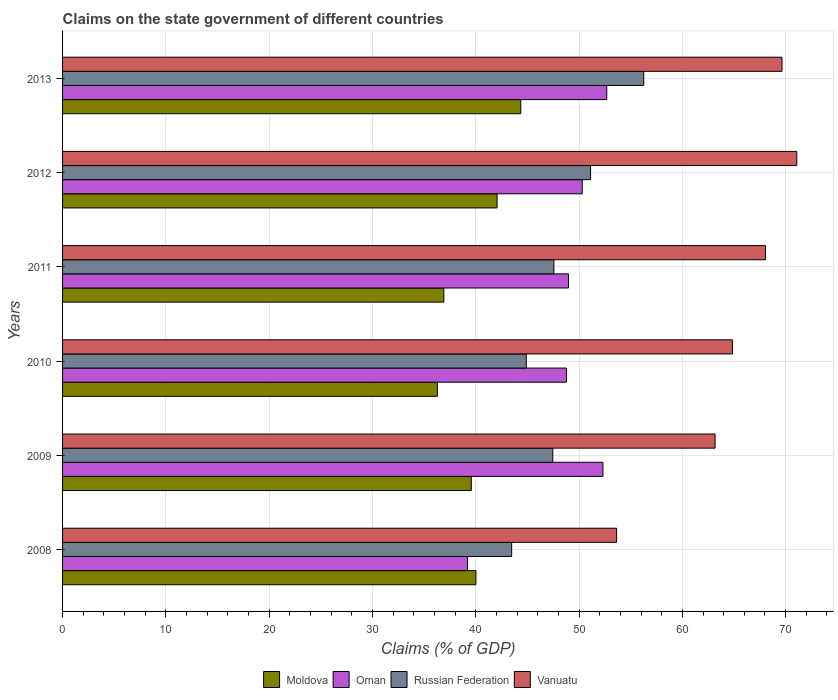How many groups of bars are there?
Ensure brevity in your answer.  6. What is the label of the 1st group of bars from the top?
Keep it short and to the point. 2013. What is the percentage of GDP claimed on the state government in Vanuatu in 2012?
Your answer should be very brief. 71.08. Across all years, what is the maximum percentage of GDP claimed on the state government in Moldova?
Provide a succinct answer. 44.36. Across all years, what is the minimum percentage of GDP claimed on the state government in Russian Federation?
Your answer should be very brief. 43.48. In which year was the percentage of GDP claimed on the state government in Oman maximum?
Keep it short and to the point. 2013. In which year was the percentage of GDP claimed on the state government in Russian Federation minimum?
Make the answer very short. 2008. What is the total percentage of GDP claimed on the state government in Vanuatu in the graph?
Keep it short and to the point. 390.43. What is the difference between the percentage of GDP claimed on the state government in Oman in 2009 and that in 2010?
Offer a very short reply. 3.53. What is the difference between the percentage of GDP claimed on the state government in Moldova in 2009 and the percentage of GDP claimed on the state government in Russian Federation in 2011?
Your answer should be very brief. -8. What is the average percentage of GDP claimed on the state government in Vanuatu per year?
Your response must be concise. 65.07. In the year 2009, what is the difference between the percentage of GDP claimed on the state government in Vanuatu and percentage of GDP claimed on the state government in Russian Federation?
Give a very brief answer. 15.71. What is the ratio of the percentage of GDP claimed on the state government in Vanuatu in 2008 to that in 2010?
Your answer should be very brief. 0.83. Is the percentage of GDP claimed on the state government in Oman in 2008 less than that in 2011?
Keep it short and to the point. Yes. What is the difference between the highest and the second highest percentage of GDP claimed on the state government in Oman?
Make the answer very short. 0.37. What is the difference between the highest and the lowest percentage of GDP claimed on the state government in Vanuatu?
Your response must be concise. 17.44. Is the sum of the percentage of GDP claimed on the state government in Oman in 2010 and 2011 greater than the maximum percentage of GDP claimed on the state government in Vanuatu across all years?
Make the answer very short. Yes. Is it the case that in every year, the sum of the percentage of GDP claimed on the state government in Russian Federation and percentage of GDP claimed on the state government in Oman is greater than the sum of percentage of GDP claimed on the state government in Vanuatu and percentage of GDP claimed on the state government in Moldova?
Your answer should be compact. No. What does the 4th bar from the top in 2010 represents?
Offer a terse response. Moldova. What does the 1st bar from the bottom in 2009 represents?
Your answer should be very brief. Moldova. How many bars are there?
Provide a short and direct response. 24. How many years are there in the graph?
Your answer should be compact. 6. What is the difference between two consecutive major ticks on the X-axis?
Offer a terse response. 10. Does the graph contain any zero values?
Provide a short and direct response. No. How are the legend labels stacked?
Provide a succinct answer. Horizontal. What is the title of the graph?
Make the answer very short. Claims on the state government of different countries. What is the label or title of the X-axis?
Make the answer very short. Claims (% of GDP). What is the Claims (% of GDP) in Moldova in 2008?
Offer a terse response. 40.02. What is the Claims (% of GDP) of Oman in 2008?
Make the answer very short. 39.2. What is the Claims (% of GDP) of Russian Federation in 2008?
Your response must be concise. 43.48. What is the Claims (% of GDP) of Vanuatu in 2008?
Provide a short and direct response. 53.63. What is the Claims (% of GDP) in Moldova in 2009?
Offer a very short reply. 39.57. What is the Claims (% of GDP) of Oman in 2009?
Your response must be concise. 52.31. What is the Claims (% of GDP) of Russian Federation in 2009?
Offer a very short reply. 47.45. What is the Claims (% of GDP) in Vanuatu in 2009?
Provide a short and direct response. 63.17. What is the Claims (% of GDP) of Moldova in 2010?
Provide a short and direct response. 36.29. What is the Claims (% of GDP) of Oman in 2010?
Ensure brevity in your answer.  48.78. What is the Claims (% of GDP) of Russian Federation in 2010?
Keep it short and to the point. 44.89. What is the Claims (% of GDP) of Vanuatu in 2010?
Make the answer very short. 64.85. What is the Claims (% of GDP) of Moldova in 2011?
Make the answer very short. 36.91. What is the Claims (% of GDP) in Oman in 2011?
Give a very brief answer. 48.98. What is the Claims (% of GDP) of Russian Federation in 2011?
Make the answer very short. 47.56. What is the Claims (% of GDP) in Vanuatu in 2011?
Offer a terse response. 68.05. What is the Claims (% of GDP) in Moldova in 2012?
Make the answer very short. 42.06. What is the Claims (% of GDP) of Oman in 2012?
Offer a terse response. 50.31. What is the Claims (% of GDP) of Russian Federation in 2012?
Provide a short and direct response. 51.11. What is the Claims (% of GDP) in Vanuatu in 2012?
Provide a succinct answer. 71.08. What is the Claims (% of GDP) in Moldova in 2013?
Offer a terse response. 44.36. What is the Claims (% of GDP) of Oman in 2013?
Your response must be concise. 52.68. What is the Claims (% of GDP) of Russian Federation in 2013?
Give a very brief answer. 56.26. What is the Claims (% of GDP) in Vanuatu in 2013?
Offer a terse response. 69.65. Across all years, what is the maximum Claims (% of GDP) in Moldova?
Your answer should be very brief. 44.36. Across all years, what is the maximum Claims (% of GDP) in Oman?
Provide a succinct answer. 52.68. Across all years, what is the maximum Claims (% of GDP) of Russian Federation?
Your answer should be compact. 56.26. Across all years, what is the maximum Claims (% of GDP) in Vanuatu?
Your response must be concise. 71.08. Across all years, what is the minimum Claims (% of GDP) in Moldova?
Ensure brevity in your answer.  36.29. Across all years, what is the minimum Claims (% of GDP) of Oman?
Give a very brief answer. 39.2. Across all years, what is the minimum Claims (% of GDP) in Russian Federation?
Provide a succinct answer. 43.48. Across all years, what is the minimum Claims (% of GDP) in Vanuatu?
Make the answer very short. 53.63. What is the total Claims (% of GDP) in Moldova in the graph?
Provide a short and direct response. 239.2. What is the total Claims (% of GDP) in Oman in the graph?
Provide a succinct answer. 292.27. What is the total Claims (% of GDP) in Russian Federation in the graph?
Keep it short and to the point. 290.76. What is the total Claims (% of GDP) of Vanuatu in the graph?
Provide a short and direct response. 390.43. What is the difference between the Claims (% of GDP) in Moldova in 2008 and that in 2009?
Give a very brief answer. 0.45. What is the difference between the Claims (% of GDP) of Oman in 2008 and that in 2009?
Keep it short and to the point. -13.11. What is the difference between the Claims (% of GDP) of Russian Federation in 2008 and that in 2009?
Your response must be concise. -3.98. What is the difference between the Claims (% of GDP) of Vanuatu in 2008 and that in 2009?
Your answer should be compact. -9.53. What is the difference between the Claims (% of GDP) in Moldova in 2008 and that in 2010?
Provide a short and direct response. 3.73. What is the difference between the Claims (% of GDP) in Oman in 2008 and that in 2010?
Provide a succinct answer. -9.58. What is the difference between the Claims (% of GDP) of Russian Federation in 2008 and that in 2010?
Offer a terse response. -1.41. What is the difference between the Claims (% of GDP) of Vanuatu in 2008 and that in 2010?
Offer a terse response. -11.21. What is the difference between the Claims (% of GDP) in Moldova in 2008 and that in 2011?
Provide a succinct answer. 3.11. What is the difference between the Claims (% of GDP) of Oman in 2008 and that in 2011?
Provide a succinct answer. -9.77. What is the difference between the Claims (% of GDP) of Russian Federation in 2008 and that in 2011?
Ensure brevity in your answer.  -4.09. What is the difference between the Claims (% of GDP) in Vanuatu in 2008 and that in 2011?
Give a very brief answer. -14.42. What is the difference between the Claims (% of GDP) in Moldova in 2008 and that in 2012?
Your answer should be very brief. -2.05. What is the difference between the Claims (% of GDP) of Oman in 2008 and that in 2012?
Your response must be concise. -11.1. What is the difference between the Claims (% of GDP) of Russian Federation in 2008 and that in 2012?
Offer a very short reply. -7.64. What is the difference between the Claims (% of GDP) of Vanuatu in 2008 and that in 2012?
Offer a terse response. -17.44. What is the difference between the Claims (% of GDP) of Moldova in 2008 and that in 2013?
Ensure brevity in your answer.  -4.34. What is the difference between the Claims (% of GDP) of Oman in 2008 and that in 2013?
Your answer should be very brief. -13.48. What is the difference between the Claims (% of GDP) of Russian Federation in 2008 and that in 2013?
Give a very brief answer. -12.79. What is the difference between the Claims (% of GDP) of Vanuatu in 2008 and that in 2013?
Provide a succinct answer. -16.01. What is the difference between the Claims (% of GDP) of Moldova in 2009 and that in 2010?
Provide a short and direct response. 3.28. What is the difference between the Claims (% of GDP) of Oman in 2009 and that in 2010?
Ensure brevity in your answer.  3.53. What is the difference between the Claims (% of GDP) of Russian Federation in 2009 and that in 2010?
Give a very brief answer. 2.57. What is the difference between the Claims (% of GDP) of Vanuatu in 2009 and that in 2010?
Your answer should be compact. -1.68. What is the difference between the Claims (% of GDP) of Moldova in 2009 and that in 2011?
Offer a terse response. 2.66. What is the difference between the Claims (% of GDP) in Oman in 2009 and that in 2011?
Your response must be concise. 3.34. What is the difference between the Claims (% of GDP) in Russian Federation in 2009 and that in 2011?
Provide a short and direct response. -0.11. What is the difference between the Claims (% of GDP) of Vanuatu in 2009 and that in 2011?
Provide a short and direct response. -4.89. What is the difference between the Claims (% of GDP) of Moldova in 2009 and that in 2012?
Offer a terse response. -2.5. What is the difference between the Claims (% of GDP) of Oman in 2009 and that in 2012?
Your answer should be very brief. 2.01. What is the difference between the Claims (% of GDP) of Russian Federation in 2009 and that in 2012?
Make the answer very short. -3.66. What is the difference between the Claims (% of GDP) of Vanuatu in 2009 and that in 2012?
Offer a very short reply. -7.91. What is the difference between the Claims (% of GDP) in Moldova in 2009 and that in 2013?
Make the answer very short. -4.79. What is the difference between the Claims (% of GDP) in Oman in 2009 and that in 2013?
Provide a succinct answer. -0.37. What is the difference between the Claims (% of GDP) of Russian Federation in 2009 and that in 2013?
Keep it short and to the point. -8.81. What is the difference between the Claims (% of GDP) in Vanuatu in 2009 and that in 2013?
Provide a succinct answer. -6.48. What is the difference between the Claims (% of GDP) of Moldova in 2010 and that in 2011?
Your answer should be compact. -0.62. What is the difference between the Claims (% of GDP) of Oman in 2010 and that in 2011?
Provide a short and direct response. -0.19. What is the difference between the Claims (% of GDP) in Russian Federation in 2010 and that in 2011?
Your answer should be very brief. -2.68. What is the difference between the Claims (% of GDP) in Vanuatu in 2010 and that in 2011?
Keep it short and to the point. -3.21. What is the difference between the Claims (% of GDP) in Moldova in 2010 and that in 2012?
Keep it short and to the point. -5.78. What is the difference between the Claims (% of GDP) in Oman in 2010 and that in 2012?
Offer a terse response. -1.52. What is the difference between the Claims (% of GDP) in Russian Federation in 2010 and that in 2012?
Your answer should be compact. -6.23. What is the difference between the Claims (% of GDP) in Vanuatu in 2010 and that in 2012?
Provide a succinct answer. -6.23. What is the difference between the Claims (% of GDP) of Moldova in 2010 and that in 2013?
Give a very brief answer. -8.07. What is the difference between the Claims (% of GDP) of Oman in 2010 and that in 2013?
Ensure brevity in your answer.  -3.9. What is the difference between the Claims (% of GDP) in Russian Federation in 2010 and that in 2013?
Your answer should be very brief. -11.38. What is the difference between the Claims (% of GDP) of Vanuatu in 2010 and that in 2013?
Provide a succinct answer. -4.8. What is the difference between the Claims (% of GDP) in Moldova in 2011 and that in 2012?
Ensure brevity in your answer.  -5.15. What is the difference between the Claims (% of GDP) of Oman in 2011 and that in 2012?
Your answer should be compact. -1.33. What is the difference between the Claims (% of GDP) of Russian Federation in 2011 and that in 2012?
Your answer should be very brief. -3.55. What is the difference between the Claims (% of GDP) in Vanuatu in 2011 and that in 2012?
Keep it short and to the point. -3.02. What is the difference between the Claims (% of GDP) in Moldova in 2011 and that in 2013?
Offer a very short reply. -7.45. What is the difference between the Claims (% of GDP) of Oman in 2011 and that in 2013?
Ensure brevity in your answer.  -3.71. What is the difference between the Claims (% of GDP) in Russian Federation in 2011 and that in 2013?
Provide a succinct answer. -8.7. What is the difference between the Claims (% of GDP) of Vanuatu in 2011 and that in 2013?
Your answer should be very brief. -1.59. What is the difference between the Claims (% of GDP) in Moldova in 2012 and that in 2013?
Your response must be concise. -2.29. What is the difference between the Claims (% of GDP) of Oman in 2012 and that in 2013?
Offer a terse response. -2.38. What is the difference between the Claims (% of GDP) of Russian Federation in 2012 and that in 2013?
Your answer should be compact. -5.15. What is the difference between the Claims (% of GDP) in Vanuatu in 2012 and that in 2013?
Make the answer very short. 1.43. What is the difference between the Claims (% of GDP) of Moldova in 2008 and the Claims (% of GDP) of Oman in 2009?
Your answer should be very brief. -12.3. What is the difference between the Claims (% of GDP) of Moldova in 2008 and the Claims (% of GDP) of Russian Federation in 2009?
Ensure brevity in your answer.  -7.44. What is the difference between the Claims (% of GDP) in Moldova in 2008 and the Claims (% of GDP) in Vanuatu in 2009?
Give a very brief answer. -23.15. What is the difference between the Claims (% of GDP) in Oman in 2008 and the Claims (% of GDP) in Russian Federation in 2009?
Your response must be concise. -8.25. What is the difference between the Claims (% of GDP) of Oman in 2008 and the Claims (% of GDP) of Vanuatu in 2009?
Provide a succinct answer. -23.96. What is the difference between the Claims (% of GDP) in Russian Federation in 2008 and the Claims (% of GDP) in Vanuatu in 2009?
Your response must be concise. -19.69. What is the difference between the Claims (% of GDP) in Moldova in 2008 and the Claims (% of GDP) in Oman in 2010?
Your response must be concise. -8.77. What is the difference between the Claims (% of GDP) in Moldova in 2008 and the Claims (% of GDP) in Russian Federation in 2010?
Your answer should be compact. -4.87. What is the difference between the Claims (% of GDP) of Moldova in 2008 and the Claims (% of GDP) of Vanuatu in 2010?
Your answer should be compact. -24.83. What is the difference between the Claims (% of GDP) in Oman in 2008 and the Claims (% of GDP) in Russian Federation in 2010?
Give a very brief answer. -5.68. What is the difference between the Claims (% of GDP) of Oman in 2008 and the Claims (% of GDP) of Vanuatu in 2010?
Provide a short and direct response. -25.64. What is the difference between the Claims (% of GDP) in Russian Federation in 2008 and the Claims (% of GDP) in Vanuatu in 2010?
Your answer should be very brief. -21.37. What is the difference between the Claims (% of GDP) of Moldova in 2008 and the Claims (% of GDP) of Oman in 2011?
Provide a succinct answer. -8.96. What is the difference between the Claims (% of GDP) of Moldova in 2008 and the Claims (% of GDP) of Russian Federation in 2011?
Ensure brevity in your answer.  -7.55. What is the difference between the Claims (% of GDP) in Moldova in 2008 and the Claims (% of GDP) in Vanuatu in 2011?
Your response must be concise. -28.04. What is the difference between the Claims (% of GDP) in Oman in 2008 and the Claims (% of GDP) in Russian Federation in 2011?
Keep it short and to the point. -8.36. What is the difference between the Claims (% of GDP) in Oman in 2008 and the Claims (% of GDP) in Vanuatu in 2011?
Keep it short and to the point. -28.85. What is the difference between the Claims (% of GDP) of Russian Federation in 2008 and the Claims (% of GDP) of Vanuatu in 2011?
Your answer should be very brief. -24.58. What is the difference between the Claims (% of GDP) in Moldova in 2008 and the Claims (% of GDP) in Oman in 2012?
Offer a terse response. -10.29. What is the difference between the Claims (% of GDP) in Moldova in 2008 and the Claims (% of GDP) in Russian Federation in 2012?
Provide a short and direct response. -11.1. What is the difference between the Claims (% of GDP) of Moldova in 2008 and the Claims (% of GDP) of Vanuatu in 2012?
Your answer should be very brief. -31.06. What is the difference between the Claims (% of GDP) in Oman in 2008 and the Claims (% of GDP) in Russian Federation in 2012?
Make the answer very short. -11.91. What is the difference between the Claims (% of GDP) of Oman in 2008 and the Claims (% of GDP) of Vanuatu in 2012?
Make the answer very short. -31.87. What is the difference between the Claims (% of GDP) of Russian Federation in 2008 and the Claims (% of GDP) of Vanuatu in 2012?
Offer a very short reply. -27.6. What is the difference between the Claims (% of GDP) of Moldova in 2008 and the Claims (% of GDP) of Oman in 2013?
Your answer should be very brief. -12.67. What is the difference between the Claims (% of GDP) in Moldova in 2008 and the Claims (% of GDP) in Russian Federation in 2013?
Ensure brevity in your answer.  -16.25. What is the difference between the Claims (% of GDP) in Moldova in 2008 and the Claims (% of GDP) in Vanuatu in 2013?
Offer a very short reply. -29.63. What is the difference between the Claims (% of GDP) of Oman in 2008 and the Claims (% of GDP) of Russian Federation in 2013?
Ensure brevity in your answer.  -17.06. What is the difference between the Claims (% of GDP) in Oman in 2008 and the Claims (% of GDP) in Vanuatu in 2013?
Provide a succinct answer. -30.44. What is the difference between the Claims (% of GDP) in Russian Federation in 2008 and the Claims (% of GDP) in Vanuatu in 2013?
Offer a terse response. -26.17. What is the difference between the Claims (% of GDP) in Moldova in 2009 and the Claims (% of GDP) in Oman in 2010?
Make the answer very short. -9.21. What is the difference between the Claims (% of GDP) of Moldova in 2009 and the Claims (% of GDP) of Russian Federation in 2010?
Provide a succinct answer. -5.32. What is the difference between the Claims (% of GDP) in Moldova in 2009 and the Claims (% of GDP) in Vanuatu in 2010?
Make the answer very short. -25.28. What is the difference between the Claims (% of GDP) of Oman in 2009 and the Claims (% of GDP) of Russian Federation in 2010?
Ensure brevity in your answer.  7.42. What is the difference between the Claims (% of GDP) of Oman in 2009 and the Claims (% of GDP) of Vanuatu in 2010?
Your answer should be compact. -12.54. What is the difference between the Claims (% of GDP) in Russian Federation in 2009 and the Claims (% of GDP) in Vanuatu in 2010?
Keep it short and to the point. -17.39. What is the difference between the Claims (% of GDP) in Moldova in 2009 and the Claims (% of GDP) in Oman in 2011?
Your answer should be very brief. -9.41. What is the difference between the Claims (% of GDP) in Moldova in 2009 and the Claims (% of GDP) in Russian Federation in 2011?
Provide a short and direct response. -8. What is the difference between the Claims (% of GDP) of Moldova in 2009 and the Claims (% of GDP) of Vanuatu in 2011?
Your answer should be very brief. -28.49. What is the difference between the Claims (% of GDP) of Oman in 2009 and the Claims (% of GDP) of Russian Federation in 2011?
Your answer should be compact. 4.75. What is the difference between the Claims (% of GDP) of Oman in 2009 and the Claims (% of GDP) of Vanuatu in 2011?
Ensure brevity in your answer.  -15.74. What is the difference between the Claims (% of GDP) of Russian Federation in 2009 and the Claims (% of GDP) of Vanuatu in 2011?
Provide a succinct answer. -20.6. What is the difference between the Claims (% of GDP) of Moldova in 2009 and the Claims (% of GDP) of Oman in 2012?
Ensure brevity in your answer.  -10.74. What is the difference between the Claims (% of GDP) in Moldova in 2009 and the Claims (% of GDP) in Russian Federation in 2012?
Keep it short and to the point. -11.55. What is the difference between the Claims (% of GDP) of Moldova in 2009 and the Claims (% of GDP) of Vanuatu in 2012?
Offer a very short reply. -31.51. What is the difference between the Claims (% of GDP) in Oman in 2009 and the Claims (% of GDP) in Russian Federation in 2012?
Offer a very short reply. 1.2. What is the difference between the Claims (% of GDP) of Oman in 2009 and the Claims (% of GDP) of Vanuatu in 2012?
Your answer should be compact. -18.77. What is the difference between the Claims (% of GDP) of Russian Federation in 2009 and the Claims (% of GDP) of Vanuatu in 2012?
Keep it short and to the point. -23.62. What is the difference between the Claims (% of GDP) in Moldova in 2009 and the Claims (% of GDP) in Oman in 2013?
Provide a short and direct response. -13.11. What is the difference between the Claims (% of GDP) in Moldova in 2009 and the Claims (% of GDP) in Russian Federation in 2013?
Your answer should be compact. -16.7. What is the difference between the Claims (% of GDP) of Moldova in 2009 and the Claims (% of GDP) of Vanuatu in 2013?
Provide a succinct answer. -30.08. What is the difference between the Claims (% of GDP) in Oman in 2009 and the Claims (% of GDP) in Russian Federation in 2013?
Make the answer very short. -3.95. What is the difference between the Claims (% of GDP) in Oman in 2009 and the Claims (% of GDP) in Vanuatu in 2013?
Make the answer very short. -17.34. What is the difference between the Claims (% of GDP) in Russian Federation in 2009 and the Claims (% of GDP) in Vanuatu in 2013?
Provide a succinct answer. -22.19. What is the difference between the Claims (% of GDP) in Moldova in 2010 and the Claims (% of GDP) in Oman in 2011?
Offer a terse response. -12.69. What is the difference between the Claims (% of GDP) of Moldova in 2010 and the Claims (% of GDP) of Russian Federation in 2011?
Ensure brevity in your answer.  -11.28. What is the difference between the Claims (% of GDP) of Moldova in 2010 and the Claims (% of GDP) of Vanuatu in 2011?
Ensure brevity in your answer.  -31.77. What is the difference between the Claims (% of GDP) of Oman in 2010 and the Claims (% of GDP) of Russian Federation in 2011?
Ensure brevity in your answer.  1.22. What is the difference between the Claims (% of GDP) in Oman in 2010 and the Claims (% of GDP) in Vanuatu in 2011?
Provide a short and direct response. -19.27. What is the difference between the Claims (% of GDP) of Russian Federation in 2010 and the Claims (% of GDP) of Vanuatu in 2011?
Provide a succinct answer. -23.17. What is the difference between the Claims (% of GDP) in Moldova in 2010 and the Claims (% of GDP) in Oman in 2012?
Provide a short and direct response. -14.02. What is the difference between the Claims (% of GDP) of Moldova in 2010 and the Claims (% of GDP) of Russian Federation in 2012?
Ensure brevity in your answer.  -14.83. What is the difference between the Claims (% of GDP) of Moldova in 2010 and the Claims (% of GDP) of Vanuatu in 2012?
Offer a very short reply. -34.79. What is the difference between the Claims (% of GDP) of Oman in 2010 and the Claims (% of GDP) of Russian Federation in 2012?
Your answer should be compact. -2.33. What is the difference between the Claims (% of GDP) of Oman in 2010 and the Claims (% of GDP) of Vanuatu in 2012?
Make the answer very short. -22.3. What is the difference between the Claims (% of GDP) in Russian Federation in 2010 and the Claims (% of GDP) in Vanuatu in 2012?
Your answer should be compact. -26.19. What is the difference between the Claims (% of GDP) of Moldova in 2010 and the Claims (% of GDP) of Oman in 2013?
Keep it short and to the point. -16.4. What is the difference between the Claims (% of GDP) in Moldova in 2010 and the Claims (% of GDP) in Russian Federation in 2013?
Ensure brevity in your answer.  -19.98. What is the difference between the Claims (% of GDP) in Moldova in 2010 and the Claims (% of GDP) in Vanuatu in 2013?
Offer a very short reply. -33.36. What is the difference between the Claims (% of GDP) of Oman in 2010 and the Claims (% of GDP) of Russian Federation in 2013?
Offer a very short reply. -7.48. What is the difference between the Claims (% of GDP) of Oman in 2010 and the Claims (% of GDP) of Vanuatu in 2013?
Offer a very short reply. -20.87. What is the difference between the Claims (% of GDP) in Russian Federation in 2010 and the Claims (% of GDP) in Vanuatu in 2013?
Offer a very short reply. -24.76. What is the difference between the Claims (% of GDP) in Moldova in 2011 and the Claims (% of GDP) in Oman in 2012?
Provide a succinct answer. -13.4. What is the difference between the Claims (% of GDP) in Moldova in 2011 and the Claims (% of GDP) in Russian Federation in 2012?
Your answer should be very brief. -14.2. What is the difference between the Claims (% of GDP) of Moldova in 2011 and the Claims (% of GDP) of Vanuatu in 2012?
Your response must be concise. -34.17. What is the difference between the Claims (% of GDP) in Oman in 2011 and the Claims (% of GDP) in Russian Federation in 2012?
Ensure brevity in your answer.  -2.14. What is the difference between the Claims (% of GDP) in Oman in 2011 and the Claims (% of GDP) in Vanuatu in 2012?
Your response must be concise. -22.1. What is the difference between the Claims (% of GDP) in Russian Federation in 2011 and the Claims (% of GDP) in Vanuatu in 2012?
Offer a terse response. -23.51. What is the difference between the Claims (% of GDP) of Moldova in 2011 and the Claims (% of GDP) of Oman in 2013?
Make the answer very short. -15.77. What is the difference between the Claims (% of GDP) of Moldova in 2011 and the Claims (% of GDP) of Russian Federation in 2013?
Keep it short and to the point. -19.35. What is the difference between the Claims (% of GDP) in Moldova in 2011 and the Claims (% of GDP) in Vanuatu in 2013?
Make the answer very short. -32.74. What is the difference between the Claims (% of GDP) of Oman in 2011 and the Claims (% of GDP) of Russian Federation in 2013?
Give a very brief answer. -7.29. What is the difference between the Claims (% of GDP) of Oman in 2011 and the Claims (% of GDP) of Vanuatu in 2013?
Your answer should be very brief. -20.67. What is the difference between the Claims (% of GDP) in Russian Federation in 2011 and the Claims (% of GDP) in Vanuatu in 2013?
Your answer should be compact. -22.08. What is the difference between the Claims (% of GDP) in Moldova in 2012 and the Claims (% of GDP) in Oman in 2013?
Your response must be concise. -10.62. What is the difference between the Claims (% of GDP) in Moldova in 2012 and the Claims (% of GDP) in Russian Federation in 2013?
Offer a very short reply. -14.2. What is the difference between the Claims (% of GDP) in Moldova in 2012 and the Claims (% of GDP) in Vanuatu in 2013?
Make the answer very short. -27.58. What is the difference between the Claims (% of GDP) of Oman in 2012 and the Claims (% of GDP) of Russian Federation in 2013?
Ensure brevity in your answer.  -5.96. What is the difference between the Claims (% of GDP) of Oman in 2012 and the Claims (% of GDP) of Vanuatu in 2013?
Your response must be concise. -19.34. What is the difference between the Claims (% of GDP) of Russian Federation in 2012 and the Claims (% of GDP) of Vanuatu in 2013?
Give a very brief answer. -18.53. What is the average Claims (% of GDP) of Moldova per year?
Make the answer very short. 39.87. What is the average Claims (% of GDP) in Oman per year?
Offer a very short reply. 48.71. What is the average Claims (% of GDP) of Russian Federation per year?
Your response must be concise. 48.46. What is the average Claims (% of GDP) in Vanuatu per year?
Give a very brief answer. 65.07. In the year 2008, what is the difference between the Claims (% of GDP) in Moldova and Claims (% of GDP) in Oman?
Keep it short and to the point. 0.81. In the year 2008, what is the difference between the Claims (% of GDP) of Moldova and Claims (% of GDP) of Russian Federation?
Offer a terse response. -3.46. In the year 2008, what is the difference between the Claims (% of GDP) in Moldova and Claims (% of GDP) in Vanuatu?
Provide a short and direct response. -13.62. In the year 2008, what is the difference between the Claims (% of GDP) of Oman and Claims (% of GDP) of Russian Federation?
Offer a terse response. -4.27. In the year 2008, what is the difference between the Claims (% of GDP) of Oman and Claims (% of GDP) of Vanuatu?
Offer a terse response. -14.43. In the year 2008, what is the difference between the Claims (% of GDP) in Russian Federation and Claims (% of GDP) in Vanuatu?
Your answer should be compact. -10.16. In the year 2009, what is the difference between the Claims (% of GDP) of Moldova and Claims (% of GDP) of Oman?
Your response must be concise. -12.74. In the year 2009, what is the difference between the Claims (% of GDP) in Moldova and Claims (% of GDP) in Russian Federation?
Offer a very short reply. -7.89. In the year 2009, what is the difference between the Claims (% of GDP) in Moldova and Claims (% of GDP) in Vanuatu?
Keep it short and to the point. -23.6. In the year 2009, what is the difference between the Claims (% of GDP) of Oman and Claims (% of GDP) of Russian Federation?
Your answer should be very brief. 4.86. In the year 2009, what is the difference between the Claims (% of GDP) in Oman and Claims (% of GDP) in Vanuatu?
Offer a very short reply. -10.86. In the year 2009, what is the difference between the Claims (% of GDP) of Russian Federation and Claims (% of GDP) of Vanuatu?
Ensure brevity in your answer.  -15.71. In the year 2010, what is the difference between the Claims (% of GDP) of Moldova and Claims (% of GDP) of Oman?
Provide a succinct answer. -12.5. In the year 2010, what is the difference between the Claims (% of GDP) of Moldova and Claims (% of GDP) of Russian Federation?
Ensure brevity in your answer.  -8.6. In the year 2010, what is the difference between the Claims (% of GDP) of Moldova and Claims (% of GDP) of Vanuatu?
Offer a terse response. -28.56. In the year 2010, what is the difference between the Claims (% of GDP) of Oman and Claims (% of GDP) of Russian Federation?
Offer a very short reply. 3.9. In the year 2010, what is the difference between the Claims (% of GDP) of Oman and Claims (% of GDP) of Vanuatu?
Your answer should be very brief. -16.07. In the year 2010, what is the difference between the Claims (% of GDP) of Russian Federation and Claims (% of GDP) of Vanuatu?
Ensure brevity in your answer.  -19.96. In the year 2011, what is the difference between the Claims (% of GDP) in Moldova and Claims (% of GDP) in Oman?
Your response must be concise. -12.07. In the year 2011, what is the difference between the Claims (% of GDP) of Moldova and Claims (% of GDP) of Russian Federation?
Your answer should be very brief. -10.65. In the year 2011, what is the difference between the Claims (% of GDP) of Moldova and Claims (% of GDP) of Vanuatu?
Your response must be concise. -31.14. In the year 2011, what is the difference between the Claims (% of GDP) in Oman and Claims (% of GDP) in Russian Federation?
Offer a very short reply. 1.41. In the year 2011, what is the difference between the Claims (% of GDP) in Oman and Claims (% of GDP) in Vanuatu?
Give a very brief answer. -19.08. In the year 2011, what is the difference between the Claims (% of GDP) in Russian Federation and Claims (% of GDP) in Vanuatu?
Provide a short and direct response. -20.49. In the year 2012, what is the difference between the Claims (% of GDP) of Moldova and Claims (% of GDP) of Oman?
Offer a terse response. -8.24. In the year 2012, what is the difference between the Claims (% of GDP) of Moldova and Claims (% of GDP) of Russian Federation?
Give a very brief answer. -9.05. In the year 2012, what is the difference between the Claims (% of GDP) in Moldova and Claims (% of GDP) in Vanuatu?
Ensure brevity in your answer.  -29.01. In the year 2012, what is the difference between the Claims (% of GDP) in Oman and Claims (% of GDP) in Russian Federation?
Give a very brief answer. -0.81. In the year 2012, what is the difference between the Claims (% of GDP) in Oman and Claims (% of GDP) in Vanuatu?
Provide a short and direct response. -20.77. In the year 2012, what is the difference between the Claims (% of GDP) of Russian Federation and Claims (% of GDP) of Vanuatu?
Give a very brief answer. -19.96. In the year 2013, what is the difference between the Claims (% of GDP) of Moldova and Claims (% of GDP) of Oman?
Your response must be concise. -8.32. In the year 2013, what is the difference between the Claims (% of GDP) in Moldova and Claims (% of GDP) in Russian Federation?
Offer a terse response. -11.91. In the year 2013, what is the difference between the Claims (% of GDP) in Moldova and Claims (% of GDP) in Vanuatu?
Keep it short and to the point. -25.29. In the year 2013, what is the difference between the Claims (% of GDP) in Oman and Claims (% of GDP) in Russian Federation?
Offer a very short reply. -3.58. In the year 2013, what is the difference between the Claims (% of GDP) in Oman and Claims (% of GDP) in Vanuatu?
Give a very brief answer. -16.97. In the year 2013, what is the difference between the Claims (% of GDP) of Russian Federation and Claims (% of GDP) of Vanuatu?
Your answer should be very brief. -13.39. What is the ratio of the Claims (% of GDP) in Moldova in 2008 to that in 2009?
Give a very brief answer. 1.01. What is the ratio of the Claims (% of GDP) in Oman in 2008 to that in 2009?
Make the answer very short. 0.75. What is the ratio of the Claims (% of GDP) in Russian Federation in 2008 to that in 2009?
Your answer should be very brief. 0.92. What is the ratio of the Claims (% of GDP) in Vanuatu in 2008 to that in 2009?
Make the answer very short. 0.85. What is the ratio of the Claims (% of GDP) of Moldova in 2008 to that in 2010?
Provide a short and direct response. 1.1. What is the ratio of the Claims (% of GDP) in Oman in 2008 to that in 2010?
Your response must be concise. 0.8. What is the ratio of the Claims (% of GDP) of Russian Federation in 2008 to that in 2010?
Your answer should be very brief. 0.97. What is the ratio of the Claims (% of GDP) in Vanuatu in 2008 to that in 2010?
Offer a terse response. 0.83. What is the ratio of the Claims (% of GDP) in Moldova in 2008 to that in 2011?
Provide a short and direct response. 1.08. What is the ratio of the Claims (% of GDP) of Oman in 2008 to that in 2011?
Give a very brief answer. 0.8. What is the ratio of the Claims (% of GDP) of Russian Federation in 2008 to that in 2011?
Provide a succinct answer. 0.91. What is the ratio of the Claims (% of GDP) of Vanuatu in 2008 to that in 2011?
Offer a terse response. 0.79. What is the ratio of the Claims (% of GDP) of Moldova in 2008 to that in 2012?
Give a very brief answer. 0.95. What is the ratio of the Claims (% of GDP) of Oman in 2008 to that in 2012?
Make the answer very short. 0.78. What is the ratio of the Claims (% of GDP) of Russian Federation in 2008 to that in 2012?
Your response must be concise. 0.85. What is the ratio of the Claims (% of GDP) of Vanuatu in 2008 to that in 2012?
Offer a very short reply. 0.75. What is the ratio of the Claims (% of GDP) in Moldova in 2008 to that in 2013?
Your answer should be very brief. 0.9. What is the ratio of the Claims (% of GDP) of Oman in 2008 to that in 2013?
Offer a terse response. 0.74. What is the ratio of the Claims (% of GDP) of Russian Federation in 2008 to that in 2013?
Provide a short and direct response. 0.77. What is the ratio of the Claims (% of GDP) in Vanuatu in 2008 to that in 2013?
Make the answer very short. 0.77. What is the ratio of the Claims (% of GDP) in Moldova in 2009 to that in 2010?
Your response must be concise. 1.09. What is the ratio of the Claims (% of GDP) in Oman in 2009 to that in 2010?
Ensure brevity in your answer.  1.07. What is the ratio of the Claims (% of GDP) in Russian Federation in 2009 to that in 2010?
Make the answer very short. 1.06. What is the ratio of the Claims (% of GDP) of Vanuatu in 2009 to that in 2010?
Keep it short and to the point. 0.97. What is the ratio of the Claims (% of GDP) of Moldova in 2009 to that in 2011?
Offer a very short reply. 1.07. What is the ratio of the Claims (% of GDP) of Oman in 2009 to that in 2011?
Your answer should be very brief. 1.07. What is the ratio of the Claims (% of GDP) of Vanuatu in 2009 to that in 2011?
Your answer should be compact. 0.93. What is the ratio of the Claims (% of GDP) in Moldova in 2009 to that in 2012?
Your answer should be compact. 0.94. What is the ratio of the Claims (% of GDP) in Oman in 2009 to that in 2012?
Make the answer very short. 1.04. What is the ratio of the Claims (% of GDP) in Russian Federation in 2009 to that in 2012?
Provide a succinct answer. 0.93. What is the ratio of the Claims (% of GDP) in Vanuatu in 2009 to that in 2012?
Provide a succinct answer. 0.89. What is the ratio of the Claims (% of GDP) of Moldova in 2009 to that in 2013?
Make the answer very short. 0.89. What is the ratio of the Claims (% of GDP) of Oman in 2009 to that in 2013?
Keep it short and to the point. 0.99. What is the ratio of the Claims (% of GDP) in Russian Federation in 2009 to that in 2013?
Ensure brevity in your answer.  0.84. What is the ratio of the Claims (% of GDP) in Vanuatu in 2009 to that in 2013?
Your response must be concise. 0.91. What is the ratio of the Claims (% of GDP) in Moldova in 2010 to that in 2011?
Your answer should be compact. 0.98. What is the ratio of the Claims (% of GDP) of Oman in 2010 to that in 2011?
Your answer should be compact. 1. What is the ratio of the Claims (% of GDP) in Russian Federation in 2010 to that in 2011?
Your answer should be compact. 0.94. What is the ratio of the Claims (% of GDP) of Vanuatu in 2010 to that in 2011?
Make the answer very short. 0.95. What is the ratio of the Claims (% of GDP) of Moldova in 2010 to that in 2012?
Your response must be concise. 0.86. What is the ratio of the Claims (% of GDP) in Oman in 2010 to that in 2012?
Give a very brief answer. 0.97. What is the ratio of the Claims (% of GDP) in Russian Federation in 2010 to that in 2012?
Your response must be concise. 0.88. What is the ratio of the Claims (% of GDP) of Vanuatu in 2010 to that in 2012?
Give a very brief answer. 0.91. What is the ratio of the Claims (% of GDP) of Moldova in 2010 to that in 2013?
Your answer should be compact. 0.82. What is the ratio of the Claims (% of GDP) of Oman in 2010 to that in 2013?
Your response must be concise. 0.93. What is the ratio of the Claims (% of GDP) in Russian Federation in 2010 to that in 2013?
Keep it short and to the point. 0.8. What is the ratio of the Claims (% of GDP) of Vanuatu in 2010 to that in 2013?
Your answer should be very brief. 0.93. What is the ratio of the Claims (% of GDP) in Moldova in 2011 to that in 2012?
Give a very brief answer. 0.88. What is the ratio of the Claims (% of GDP) of Oman in 2011 to that in 2012?
Provide a succinct answer. 0.97. What is the ratio of the Claims (% of GDP) in Russian Federation in 2011 to that in 2012?
Provide a succinct answer. 0.93. What is the ratio of the Claims (% of GDP) of Vanuatu in 2011 to that in 2012?
Give a very brief answer. 0.96. What is the ratio of the Claims (% of GDP) of Moldova in 2011 to that in 2013?
Your answer should be very brief. 0.83. What is the ratio of the Claims (% of GDP) of Oman in 2011 to that in 2013?
Your response must be concise. 0.93. What is the ratio of the Claims (% of GDP) in Russian Federation in 2011 to that in 2013?
Provide a short and direct response. 0.85. What is the ratio of the Claims (% of GDP) of Vanuatu in 2011 to that in 2013?
Provide a short and direct response. 0.98. What is the ratio of the Claims (% of GDP) of Moldova in 2012 to that in 2013?
Provide a succinct answer. 0.95. What is the ratio of the Claims (% of GDP) of Oman in 2012 to that in 2013?
Offer a terse response. 0.95. What is the ratio of the Claims (% of GDP) in Russian Federation in 2012 to that in 2013?
Your answer should be very brief. 0.91. What is the ratio of the Claims (% of GDP) of Vanuatu in 2012 to that in 2013?
Ensure brevity in your answer.  1.02. What is the difference between the highest and the second highest Claims (% of GDP) of Moldova?
Ensure brevity in your answer.  2.29. What is the difference between the highest and the second highest Claims (% of GDP) in Oman?
Offer a very short reply. 0.37. What is the difference between the highest and the second highest Claims (% of GDP) of Russian Federation?
Provide a short and direct response. 5.15. What is the difference between the highest and the second highest Claims (% of GDP) in Vanuatu?
Ensure brevity in your answer.  1.43. What is the difference between the highest and the lowest Claims (% of GDP) in Moldova?
Give a very brief answer. 8.07. What is the difference between the highest and the lowest Claims (% of GDP) of Oman?
Your answer should be compact. 13.48. What is the difference between the highest and the lowest Claims (% of GDP) in Russian Federation?
Your answer should be very brief. 12.79. What is the difference between the highest and the lowest Claims (% of GDP) in Vanuatu?
Offer a very short reply. 17.44. 